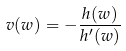Convert formula to latex. <formula><loc_0><loc_0><loc_500><loc_500>v ( w ) = - \frac { h ( w ) } { h ^ { \prime } ( w ) }</formula> 